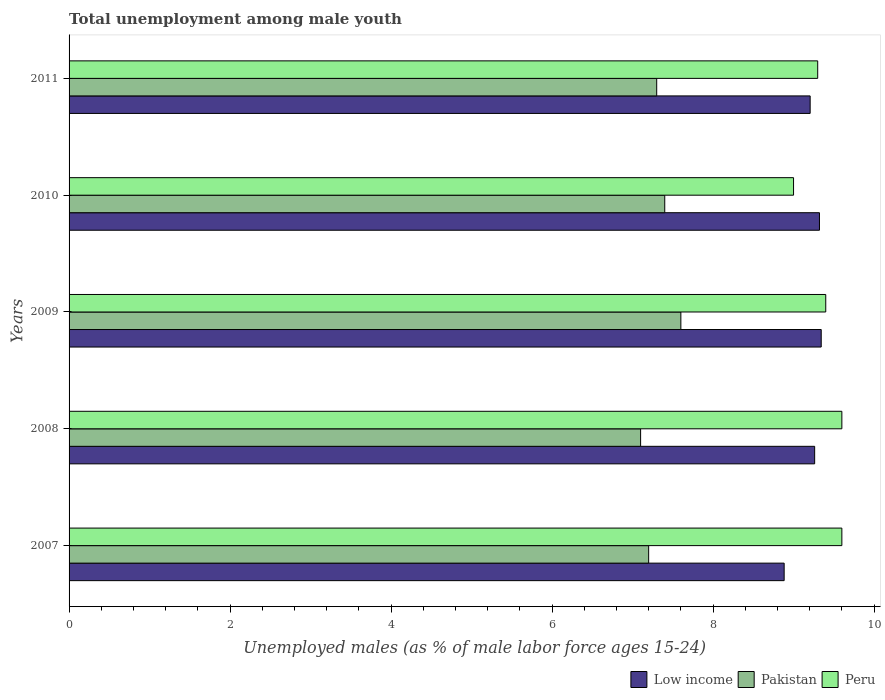How many groups of bars are there?
Your response must be concise. 5. In how many cases, is the number of bars for a given year not equal to the number of legend labels?
Give a very brief answer. 0. What is the percentage of unemployed males in in Peru in 2011?
Offer a terse response. 9.3. Across all years, what is the maximum percentage of unemployed males in in Low income?
Provide a succinct answer. 9.34. Across all years, what is the minimum percentage of unemployed males in in Low income?
Provide a succinct answer. 8.88. In which year was the percentage of unemployed males in in Peru maximum?
Ensure brevity in your answer.  2007. In which year was the percentage of unemployed males in in Pakistan minimum?
Offer a terse response. 2008. What is the total percentage of unemployed males in in Pakistan in the graph?
Ensure brevity in your answer.  36.6. What is the difference between the percentage of unemployed males in in Peru in 2007 and that in 2009?
Provide a succinct answer. 0.2. What is the difference between the percentage of unemployed males in in Pakistan in 2010 and the percentage of unemployed males in in Peru in 2011?
Provide a succinct answer. -1.9. What is the average percentage of unemployed males in in Low income per year?
Keep it short and to the point. 9.2. In the year 2008, what is the difference between the percentage of unemployed males in in Low income and percentage of unemployed males in in Peru?
Ensure brevity in your answer.  -0.34. In how many years, is the percentage of unemployed males in in Pakistan greater than 6.8 %?
Provide a succinct answer. 5. What is the ratio of the percentage of unemployed males in in Pakistan in 2010 to that in 2011?
Your answer should be very brief. 1.01. What is the difference between the highest and the second highest percentage of unemployed males in in Pakistan?
Your response must be concise. 0.2. What is the difference between the highest and the lowest percentage of unemployed males in in Peru?
Your answer should be very brief. 0.6. What does the 3rd bar from the top in 2010 represents?
Ensure brevity in your answer.  Low income. What does the 1st bar from the bottom in 2007 represents?
Ensure brevity in your answer.  Low income. Is it the case that in every year, the sum of the percentage of unemployed males in in Peru and percentage of unemployed males in in Pakistan is greater than the percentage of unemployed males in in Low income?
Keep it short and to the point. Yes. How many bars are there?
Make the answer very short. 15. Does the graph contain any zero values?
Provide a short and direct response. No. Does the graph contain grids?
Your answer should be very brief. No. What is the title of the graph?
Your answer should be very brief. Total unemployment among male youth. What is the label or title of the X-axis?
Keep it short and to the point. Unemployed males (as % of male labor force ages 15-24). What is the label or title of the Y-axis?
Give a very brief answer. Years. What is the Unemployed males (as % of male labor force ages 15-24) of Low income in 2007?
Make the answer very short. 8.88. What is the Unemployed males (as % of male labor force ages 15-24) in Pakistan in 2007?
Keep it short and to the point. 7.2. What is the Unemployed males (as % of male labor force ages 15-24) of Peru in 2007?
Your answer should be compact. 9.6. What is the Unemployed males (as % of male labor force ages 15-24) of Low income in 2008?
Make the answer very short. 9.26. What is the Unemployed males (as % of male labor force ages 15-24) of Pakistan in 2008?
Provide a succinct answer. 7.1. What is the Unemployed males (as % of male labor force ages 15-24) in Peru in 2008?
Your response must be concise. 9.6. What is the Unemployed males (as % of male labor force ages 15-24) of Low income in 2009?
Make the answer very short. 9.34. What is the Unemployed males (as % of male labor force ages 15-24) in Pakistan in 2009?
Your answer should be compact. 7.6. What is the Unemployed males (as % of male labor force ages 15-24) in Peru in 2009?
Make the answer very short. 9.4. What is the Unemployed males (as % of male labor force ages 15-24) in Low income in 2010?
Offer a very short reply. 9.32. What is the Unemployed males (as % of male labor force ages 15-24) of Pakistan in 2010?
Offer a terse response. 7.4. What is the Unemployed males (as % of male labor force ages 15-24) of Peru in 2010?
Give a very brief answer. 9. What is the Unemployed males (as % of male labor force ages 15-24) of Low income in 2011?
Your answer should be compact. 9.21. What is the Unemployed males (as % of male labor force ages 15-24) in Pakistan in 2011?
Your response must be concise. 7.3. What is the Unemployed males (as % of male labor force ages 15-24) of Peru in 2011?
Your response must be concise. 9.3. Across all years, what is the maximum Unemployed males (as % of male labor force ages 15-24) of Low income?
Provide a succinct answer. 9.34. Across all years, what is the maximum Unemployed males (as % of male labor force ages 15-24) in Pakistan?
Offer a very short reply. 7.6. Across all years, what is the maximum Unemployed males (as % of male labor force ages 15-24) of Peru?
Give a very brief answer. 9.6. Across all years, what is the minimum Unemployed males (as % of male labor force ages 15-24) of Low income?
Provide a short and direct response. 8.88. Across all years, what is the minimum Unemployed males (as % of male labor force ages 15-24) of Pakistan?
Give a very brief answer. 7.1. What is the total Unemployed males (as % of male labor force ages 15-24) in Low income in the graph?
Ensure brevity in your answer.  46.02. What is the total Unemployed males (as % of male labor force ages 15-24) of Pakistan in the graph?
Keep it short and to the point. 36.6. What is the total Unemployed males (as % of male labor force ages 15-24) of Peru in the graph?
Keep it short and to the point. 46.9. What is the difference between the Unemployed males (as % of male labor force ages 15-24) of Low income in 2007 and that in 2008?
Offer a very short reply. -0.38. What is the difference between the Unemployed males (as % of male labor force ages 15-24) of Pakistan in 2007 and that in 2008?
Keep it short and to the point. 0.1. What is the difference between the Unemployed males (as % of male labor force ages 15-24) of Low income in 2007 and that in 2009?
Offer a very short reply. -0.46. What is the difference between the Unemployed males (as % of male labor force ages 15-24) in Peru in 2007 and that in 2009?
Your response must be concise. 0.2. What is the difference between the Unemployed males (as % of male labor force ages 15-24) in Low income in 2007 and that in 2010?
Give a very brief answer. -0.44. What is the difference between the Unemployed males (as % of male labor force ages 15-24) of Low income in 2007 and that in 2011?
Your answer should be very brief. -0.32. What is the difference between the Unemployed males (as % of male labor force ages 15-24) in Pakistan in 2007 and that in 2011?
Offer a very short reply. -0.1. What is the difference between the Unemployed males (as % of male labor force ages 15-24) of Peru in 2007 and that in 2011?
Offer a very short reply. 0.3. What is the difference between the Unemployed males (as % of male labor force ages 15-24) of Low income in 2008 and that in 2009?
Make the answer very short. -0.08. What is the difference between the Unemployed males (as % of male labor force ages 15-24) in Pakistan in 2008 and that in 2009?
Your answer should be compact. -0.5. What is the difference between the Unemployed males (as % of male labor force ages 15-24) of Peru in 2008 and that in 2009?
Make the answer very short. 0.2. What is the difference between the Unemployed males (as % of male labor force ages 15-24) of Low income in 2008 and that in 2010?
Keep it short and to the point. -0.06. What is the difference between the Unemployed males (as % of male labor force ages 15-24) of Peru in 2008 and that in 2010?
Your answer should be compact. 0.6. What is the difference between the Unemployed males (as % of male labor force ages 15-24) of Low income in 2008 and that in 2011?
Ensure brevity in your answer.  0.06. What is the difference between the Unemployed males (as % of male labor force ages 15-24) of Pakistan in 2008 and that in 2011?
Offer a very short reply. -0.2. What is the difference between the Unemployed males (as % of male labor force ages 15-24) of Low income in 2009 and that in 2010?
Offer a very short reply. 0.02. What is the difference between the Unemployed males (as % of male labor force ages 15-24) of Peru in 2009 and that in 2010?
Your response must be concise. 0.4. What is the difference between the Unemployed males (as % of male labor force ages 15-24) of Low income in 2009 and that in 2011?
Your answer should be compact. 0.14. What is the difference between the Unemployed males (as % of male labor force ages 15-24) in Pakistan in 2009 and that in 2011?
Make the answer very short. 0.3. What is the difference between the Unemployed males (as % of male labor force ages 15-24) in Peru in 2009 and that in 2011?
Keep it short and to the point. 0.1. What is the difference between the Unemployed males (as % of male labor force ages 15-24) of Low income in 2010 and that in 2011?
Ensure brevity in your answer.  0.12. What is the difference between the Unemployed males (as % of male labor force ages 15-24) of Pakistan in 2010 and that in 2011?
Keep it short and to the point. 0.1. What is the difference between the Unemployed males (as % of male labor force ages 15-24) in Low income in 2007 and the Unemployed males (as % of male labor force ages 15-24) in Pakistan in 2008?
Your response must be concise. 1.78. What is the difference between the Unemployed males (as % of male labor force ages 15-24) of Low income in 2007 and the Unemployed males (as % of male labor force ages 15-24) of Peru in 2008?
Provide a succinct answer. -0.72. What is the difference between the Unemployed males (as % of male labor force ages 15-24) in Low income in 2007 and the Unemployed males (as % of male labor force ages 15-24) in Pakistan in 2009?
Provide a succinct answer. 1.28. What is the difference between the Unemployed males (as % of male labor force ages 15-24) of Low income in 2007 and the Unemployed males (as % of male labor force ages 15-24) of Peru in 2009?
Offer a terse response. -0.52. What is the difference between the Unemployed males (as % of male labor force ages 15-24) of Low income in 2007 and the Unemployed males (as % of male labor force ages 15-24) of Pakistan in 2010?
Your response must be concise. 1.48. What is the difference between the Unemployed males (as % of male labor force ages 15-24) in Low income in 2007 and the Unemployed males (as % of male labor force ages 15-24) in Peru in 2010?
Offer a terse response. -0.12. What is the difference between the Unemployed males (as % of male labor force ages 15-24) in Pakistan in 2007 and the Unemployed males (as % of male labor force ages 15-24) in Peru in 2010?
Your answer should be compact. -1.8. What is the difference between the Unemployed males (as % of male labor force ages 15-24) of Low income in 2007 and the Unemployed males (as % of male labor force ages 15-24) of Pakistan in 2011?
Make the answer very short. 1.58. What is the difference between the Unemployed males (as % of male labor force ages 15-24) of Low income in 2007 and the Unemployed males (as % of male labor force ages 15-24) of Peru in 2011?
Offer a very short reply. -0.42. What is the difference between the Unemployed males (as % of male labor force ages 15-24) in Pakistan in 2007 and the Unemployed males (as % of male labor force ages 15-24) in Peru in 2011?
Provide a short and direct response. -2.1. What is the difference between the Unemployed males (as % of male labor force ages 15-24) in Low income in 2008 and the Unemployed males (as % of male labor force ages 15-24) in Pakistan in 2009?
Give a very brief answer. 1.66. What is the difference between the Unemployed males (as % of male labor force ages 15-24) of Low income in 2008 and the Unemployed males (as % of male labor force ages 15-24) of Peru in 2009?
Give a very brief answer. -0.14. What is the difference between the Unemployed males (as % of male labor force ages 15-24) of Low income in 2008 and the Unemployed males (as % of male labor force ages 15-24) of Pakistan in 2010?
Your response must be concise. 1.86. What is the difference between the Unemployed males (as % of male labor force ages 15-24) of Low income in 2008 and the Unemployed males (as % of male labor force ages 15-24) of Peru in 2010?
Your answer should be compact. 0.26. What is the difference between the Unemployed males (as % of male labor force ages 15-24) of Pakistan in 2008 and the Unemployed males (as % of male labor force ages 15-24) of Peru in 2010?
Your answer should be compact. -1.9. What is the difference between the Unemployed males (as % of male labor force ages 15-24) of Low income in 2008 and the Unemployed males (as % of male labor force ages 15-24) of Pakistan in 2011?
Offer a very short reply. 1.96. What is the difference between the Unemployed males (as % of male labor force ages 15-24) of Low income in 2008 and the Unemployed males (as % of male labor force ages 15-24) of Peru in 2011?
Offer a terse response. -0.04. What is the difference between the Unemployed males (as % of male labor force ages 15-24) in Pakistan in 2008 and the Unemployed males (as % of male labor force ages 15-24) in Peru in 2011?
Provide a short and direct response. -2.2. What is the difference between the Unemployed males (as % of male labor force ages 15-24) in Low income in 2009 and the Unemployed males (as % of male labor force ages 15-24) in Pakistan in 2010?
Make the answer very short. 1.94. What is the difference between the Unemployed males (as % of male labor force ages 15-24) of Low income in 2009 and the Unemployed males (as % of male labor force ages 15-24) of Peru in 2010?
Provide a short and direct response. 0.34. What is the difference between the Unemployed males (as % of male labor force ages 15-24) in Low income in 2009 and the Unemployed males (as % of male labor force ages 15-24) in Pakistan in 2011?
Your answer should be compact. 2.04. What is the difference between the Unemployed males (as % of male labor force ages 15-24) of Low income in 2009 and the Unemployed males (as % of male labor force ages 15-24) of Peru in 2011?
Make the answer very short. 0.04. What is the difference between the Unemployed males (as % of male labor force ages 15-24) of Low income in 2010 and the Unemployed males (as % of male labor force ages 15-24) of Pakistan in 2011?
Provide a succinct answer. 2.02. What is the difference between the Unemployed males (as % of male labor force ages 15-24) in Low income in 2010 and the Unemployed males (as % of male labor force ages 15-24) in Peru in 2011?
Offer a terse response. 0.02. What is the difference between the Unemployed males (as % of male labor force ages 15-24) of Pakistan in 2010 and the Unemployed males (as % of male labor force ages 15-24) of Peru in 2011?
Provide a succinct answer. -1.9. What is the average Unemployed males (as % of male labor force ages 15-24) of Low income per year?
Make the answer very short. 9.2. What is the average Unemployed males (as % of male labor force ages 15-24) in Pakistan per year?
Provide a short and direct response. 7.32. What is the average Unemployed males (as % of male labor force ages 15-24) in Peru per year?
Make the answer very short. 9.38. In the year 2007, what is the difference between the Unemployed males (as % of male labor force ages 15-24) in Low income and Unemployed males (as % of male labor force ages 15-24) in Pakistan?
Give a very brief answer. 1.68. In the year 2007, what is the difference between the Unemployed males (as % of male labor force ages 15-24) of Low income and Unemployed males (as % of male labor force ages 15-24) of Peru?
Provide a succinct answer. -0.72. In the year 2008, what is the difference between the Unemployed males (as % of male labor force ages 15-24) in Low income and Unemployed males (as % of male labor force ages 15-24) in Pakistan?
Your answer should be very brief. 2.16. In the year 2008, what is the difference between the Unemployed males (as % of male labor force ages 15-24) of Low income and Unemployed males (as % of male labor force ages 15-24) of Peru?
Ensure brevity in your answer.  -0.34. In the year 2009, what is the difference between the Unemployed males (as % of male labor force ages 15-24) of Low income and Unemployed males (as % of male labor force ages 15-24) of Pakistan?
Provide a succinct answer. 1.74. In the year 2009, what is the difference between the Unemployed males (as % of male labor force ages 15-24) in Low income and Unemployed males (as % of male labor force ages 15-24) in Peru?
Ensure brevity in your answer.  -0.06. In the year 2009, what is the difference between the Unemployed males (as % of male labor force ages 15-24) of Pakistan and Unemployed males (as % of male labor force ages 15-24) of Peru?
Ensure brevity in your answer.  -1.8. In the year 2010, what is the difference between the Unemployed males (as % of male labor force ages 15-24) in Low income and Unemployed males (as % of male labor force ages 15-24) in Pakistan?
Give a very brief answer. 1.92. In the year 2010, what is the difference between the Unemployed males (as % of male labor force ages 15-24) in Low income and Unemployed males (as % of male labor force ages 15-24) in Peru?
Offer a terse response. 0.32. In the year 2011, what is the difference between the Unemployed males (as % of male labor force ages 15-24) of Low income and Unemployed males (as % of male labor force ages 15-24) of Pakistan?
Your response must be concise. 1.91. In the year 2011, what is the difference between the Unemployed males (as % of male labor force ages 15-24) of Low income and Unemployed males (as % of male labor force ages 15-24) of Peru?
Your answer should be very brief. -0.09. What is the ratio of the Unemployed males (as % of male labor force ages 15-24) of Low income in 2007 to that in 2008?
Provide a short and direct response. 0.96. What is the ratio of the Unemployed males (as % of male labor force ages 15-24) of Pakistan in 2007 to that in 2008?
Your answer should be compact. 1.01. What is the ratio of the Unemployed males (as % of male labor force ages 15-24) in Low income in 2007 to that in 2009?
Give a very brief answer. 0.95. What is the ratio of the Unemployed males (as % of male labor force ages 15-24) of Peru in 2007 to that in 2009?
Ensure brevity in your answer.  1.02. What is the ratio of the Unemployed males (as % of male labor force ages 15-24) of Low income in 2007 to that in 2010?
Keep it short and to the point. 0.95. What is the ratio of the Unemployed males (as % of male labor force ages 15-24) of Peru in 2007 to that in 2010?
Offer a terse response. 1.07. What is the ratio of the Unemployed males (as % of male labor force ages 15-24) of Low income in 2007 to that in 2011?
Provide a succinct answer. 0.96. What is the ratio of the Unemployed males (as % of male labor force ages 15-24) in Pakistan in 2007 to that in 2011?
Your answer should be very brief. 0.99. What is the ratio of the Unemployed males (as % of male labor force ages 15-24) in Peru in 2007 to that in 2011?
Your answer should be very brief. 1.03. What is the ratio of the Unemployed males (as % of male labor force ages 15-24) in Low income in 2008 to that in 2009?
Offer a terse response. 0.99. What is the ratio of the Unemployed males (as % of male labor force ages 15-24) of Pakistan in 2008 to that in 2009?
Ensure brevity in your answer.  0.93. What is the ratio of the Unemployed males (as % of male labor force ages 15-24) in Peru in 2008 to that in 2009?
Your answer should be very brief. 1.02. What is the ratio of the Unemployed males (as % of male labor force ages 15-24) of Pakistan in 2008 to that in 2010?
Ensure brevity in your answer.  0.96. What is the ratio of the Unemployed males (as % of male labor force ages 15-24) of Peru in 2008 to that in 2010?
Offer a very short reply. 1.07. What is the ratio of the Unemployed males (as % of male labor force ages 15-24) of Low income in 2008 to that in 2011?
Ensure brevity in your answer.  1.01. What is the ratio of the Unemployed males (as % of male labor force ages 15-24) in Pakistan in 2008 to that in 2011?
Offer a terse response. 0.97. What is the ratio of the Unemployed males (as % of male labor force ages 15-24) of Peru in 2008 to that in 2011?
Your answer should be very brief. 1.03. What is the ratio of the Unemployed males (as % of male labor force ages 15-24) of Low income in 2009 to that in 2010?
Offer a very short reply. 1. What is the ratio of the Unemployed males (as % of male labor force ages 15-24) of Peru in 2009 to that in 2010?
Your response must be concise. 1.04. What is the ratio of the Unemployed males (as % of male labor force ages 15-24) in Low income in 2009 to that in 2011?
Give a very brief answer. 1.01. What is the ratio of the Unemployed males (as % of male labor force ages 15-24) of Pakistan in 2009 to that in 2011?
Offer a very short reply. 1.04. What is the ratio of the Unemployed males (as % of male labor force ages 15-24) of Peru in 2009 to that in 2011?
Your answer should be compact. 1.01. What is the ratio of the Unemployed males (as % of male labor force ages 15-24) in Low income in 2010 to that in 2011?
Ensure brevity in your answer.  1.01. What is the ratio of the Unemployed males (as % of male labor force ages 15-24) of Pakistan in 2010 to that in 2011?
Provide a succinct answer. 1.01. What is the difference between the highest and the second highest Unemployed males (as % of male labor force ages 15-24) of Low income?
Provide a short and direct response. 0.02. What is the difference between the highest and the second highest Unemployed males (as % of male labor force ages 15-24) in Pakistan?
Provide a short and direct response. 0.2. What is the difference between the highest and the lowest Unemployed males (as % of male labor force ages 15-24) of Low income?
Your answer should be very brief. 0.46. What is the difference between the highest and the lowest Unemployed males (as % of male labor force ages 15-24) of Peru?
Offer a very short reply. 0.6. 